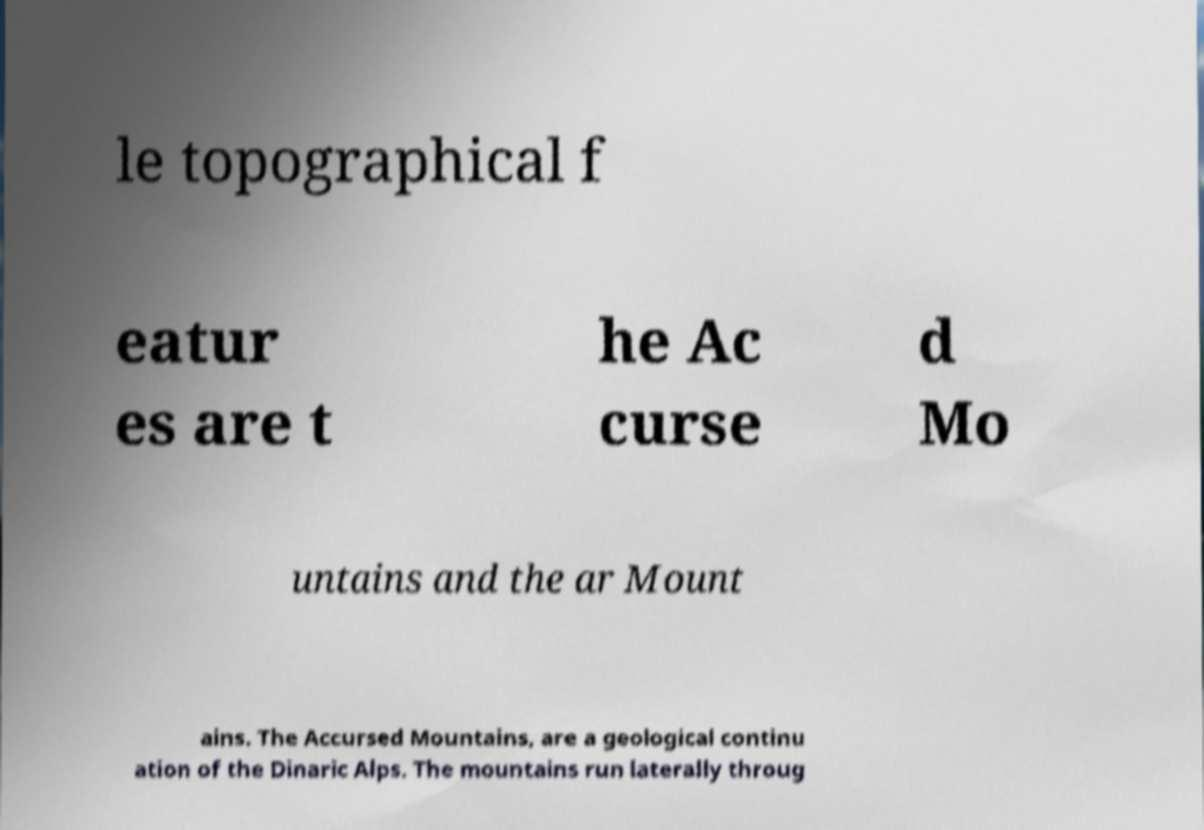Can you accurately transcribe the text from the provided image for me? le topographical f eatur es are t he Ac curse d Mo untains and the ar Mount ains. The Accursed Mountains, are a geological continu ation of the Dinaric Alps. The mountains run laterally throug 